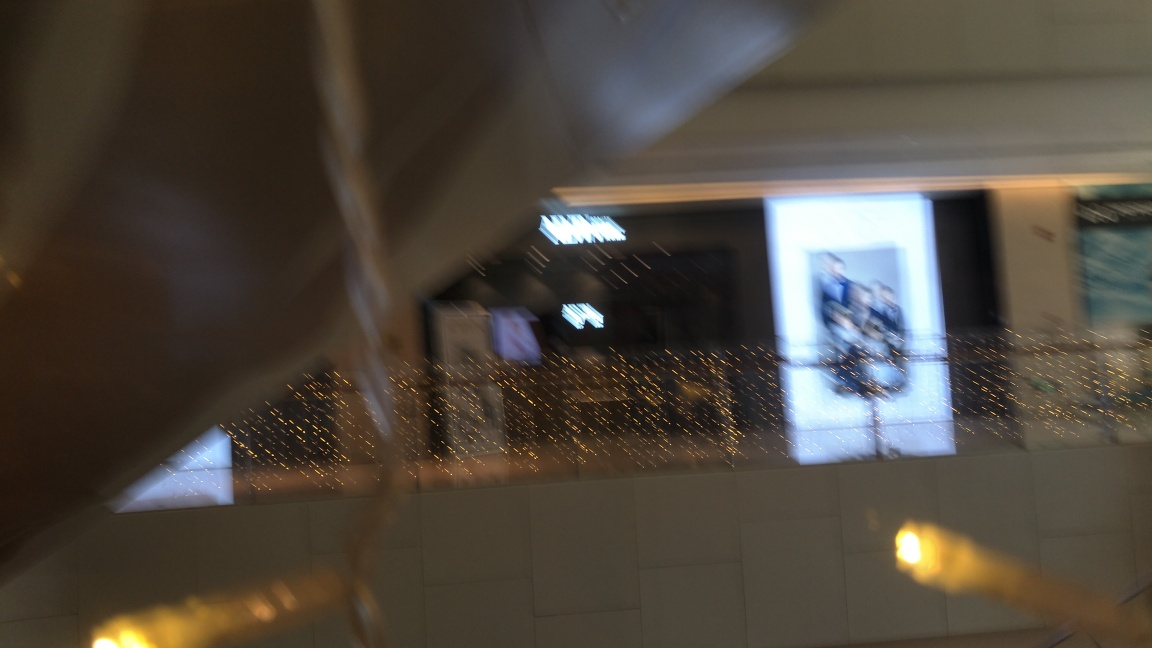Can you describe the setting or atmosphere this image suggests? The image suggests a festive or celebratory atmosphere, indicative of an indoor space decorated with string lights that provide a warm, ambient glow. However, the blurriness adds a sense of motion or activity in the area. 